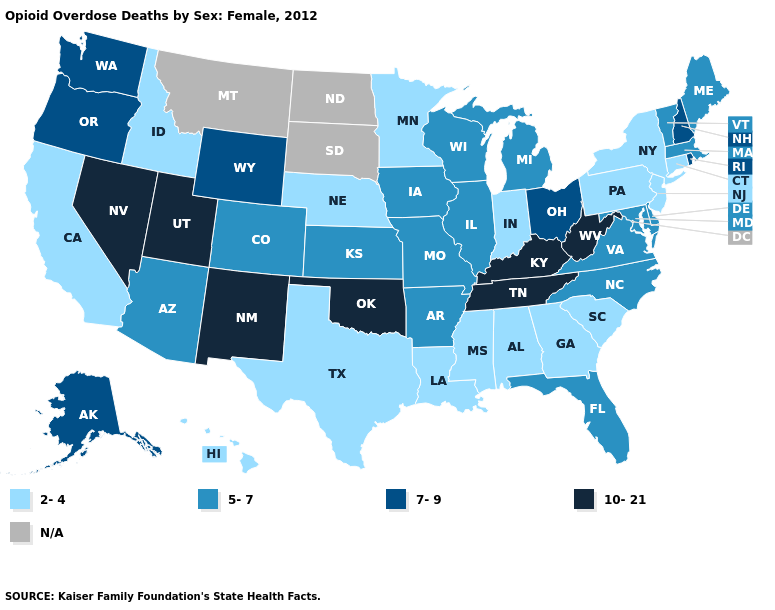How many symbols are there in the legend?
Keep it brief. 5. Among the states that border Connecticut , does Massachusetts have the highest value?
Keep it brief. No. Among the states that border Mississippi , which have the lowest value?
Short answer required. Alabama, Louisiana. Is the legend a continuous bar?
Short answer required. No. Does the map have missing data?
Write a very short answer. Yes. Does Missouri have the highest value in the USA?
Short answer required. No. How many symbols are there in the legend?
Short answer required. 5. Does Georgia have the lowest value in the USA?
Answer briefly. Yes. What is the value of Virginia?
Short answer required. 5-7. Which states hav the highest value in the Northeast?
Keep it brief. New Hampshire, Rhode Island. What is the value of Oregon?
Give a very brief answer. 7-9. What is the value of Rhode Island?
Quick response, please. 7-9. Which states have the highest value in the USA?
Concise answer only. Kentucky, Nevada, New Mexico, Oklahoma, Tennessee, Utah, West Virginia. 